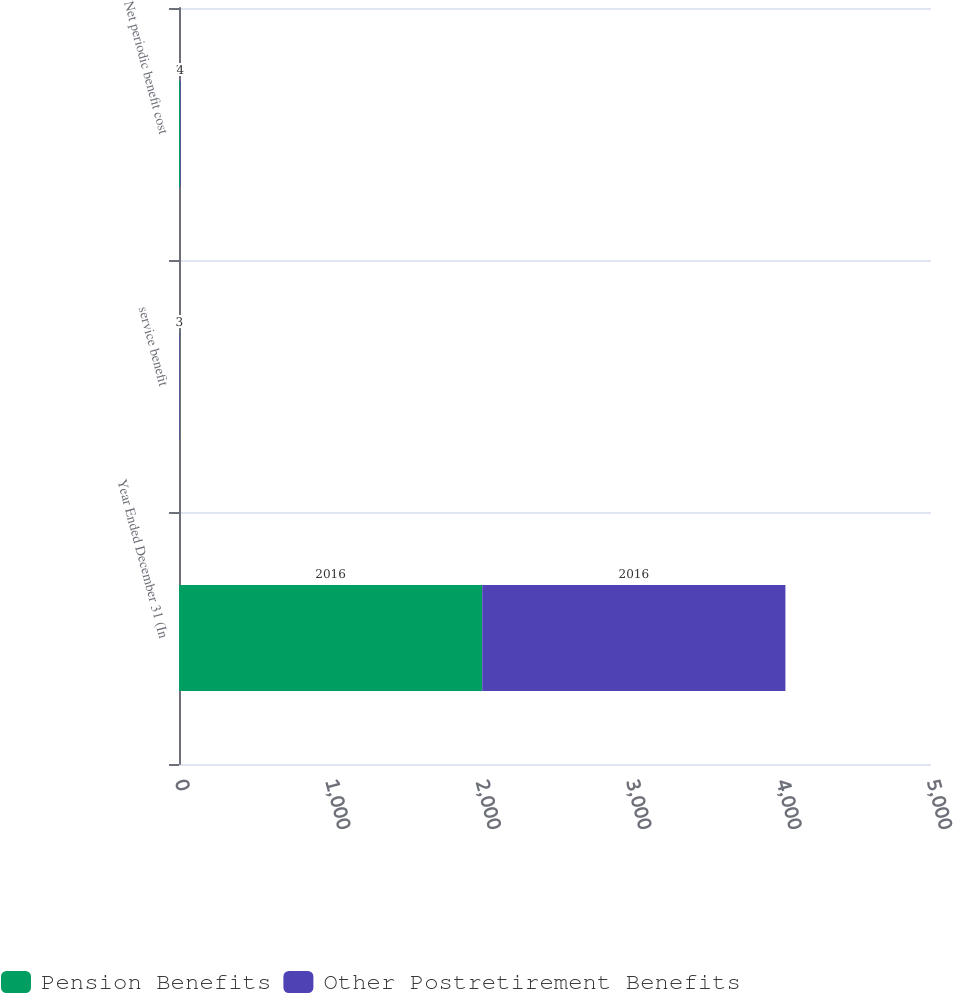Convert chart. <chart><loc_0><loc_0><loc_500><loc_500><stacked_bar_chart><ecel><fcel>Year Ended December 31 (In<fcel>service benefit<fcel>Net periodic benefit cost<nl><fcel>Pension Benefits<fcel>2016<fcel>1<fcel>7<nl><fcel>Other Postretirement Benefits<fcel>2016<fcel>3<fcel>4<nl></chart> 